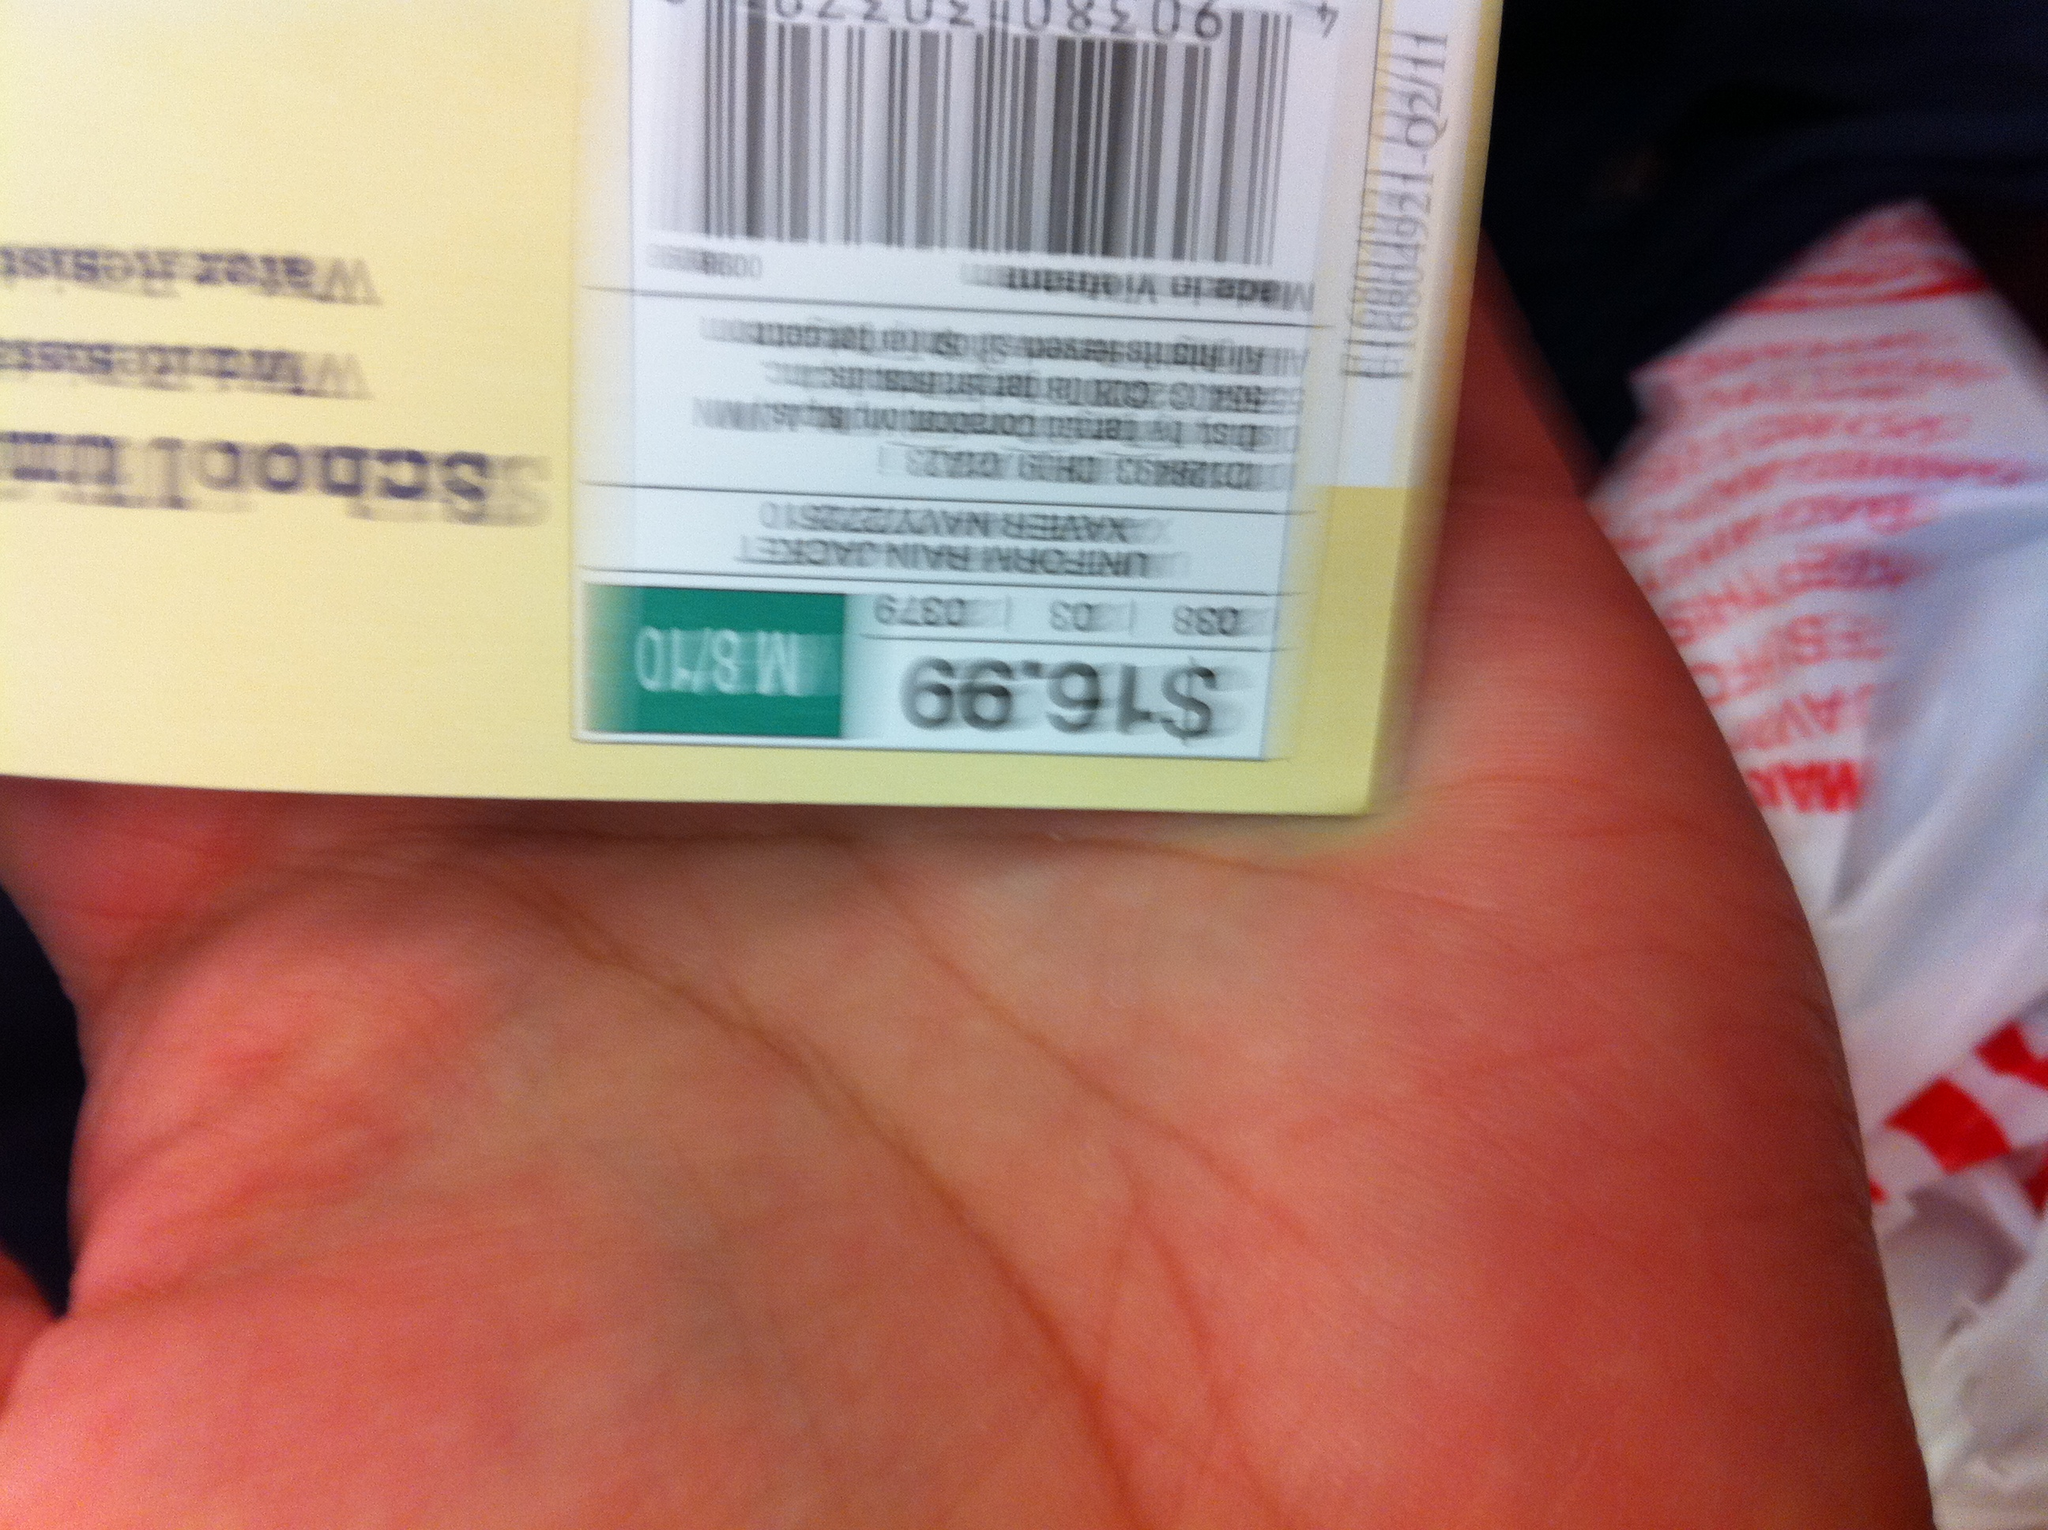What's on the tag? The price tag shows an item priced at $16.99, which appears to be attached to possibly a clothing item or accessory given the style of the tag. 